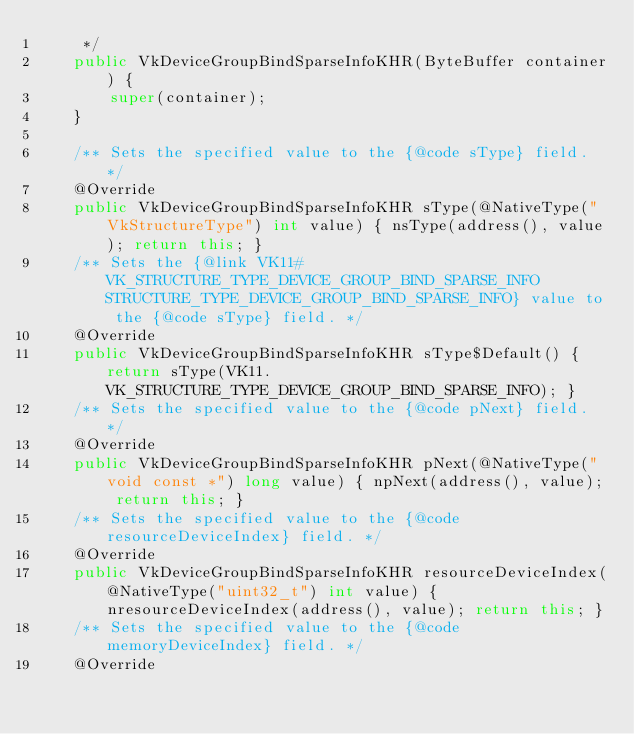<code> <loc_0><loc_0><loc_500><loc_500><_Java_>     */
    public VkDeviceGroupBindSparseInfoKHR(ByteBuffer container) {
        super(container);
    }

    /** Sets the specified value to the {@code sType} field. */
    @Override
    public VkDeviceGroupBindSparseInfoKHR sType(@NativeType("VkStructureType") int value) { nsType(address(), value); return this; }
    /** Sets the {@link VK11#VK_STRUCTURE_TYPE_DEVICE_GROUP_BIND_SPARSE_INFO STRUCTURE_TYPE_DEVICE_GROUP_BIND_SPARSE_INFO} value to the {@code sType} field. */
    @Override
    public VkDeviceGroupBindSparseInfoKHR sType$Default() { return sType(VK11.VK_STRUCTURE_TYPE_DEVICE_GROUP_BIND_SPARSE_INFO); }
    /** Sets the specified value to the {@code pNext} field. */
    @Override
    public VkDeviceGroupBindSparseInfoKHR pNext(@NativeType("void const *") long value) { npNext(address(), value); return this; }
    /** Sets the specified value to the {@code resourceDeviceIndex} field. */
    @Override
    public VkDeviceGroupBindSparseInfoKHR resourceDeviceIndex(@NativeType("uint32_t") int value) { nresourceDeviceIndex(address(), value); return this; }
    /** Sets the specified value to the {@code memoryDeviceIndex} field. */
    @Override</code> 